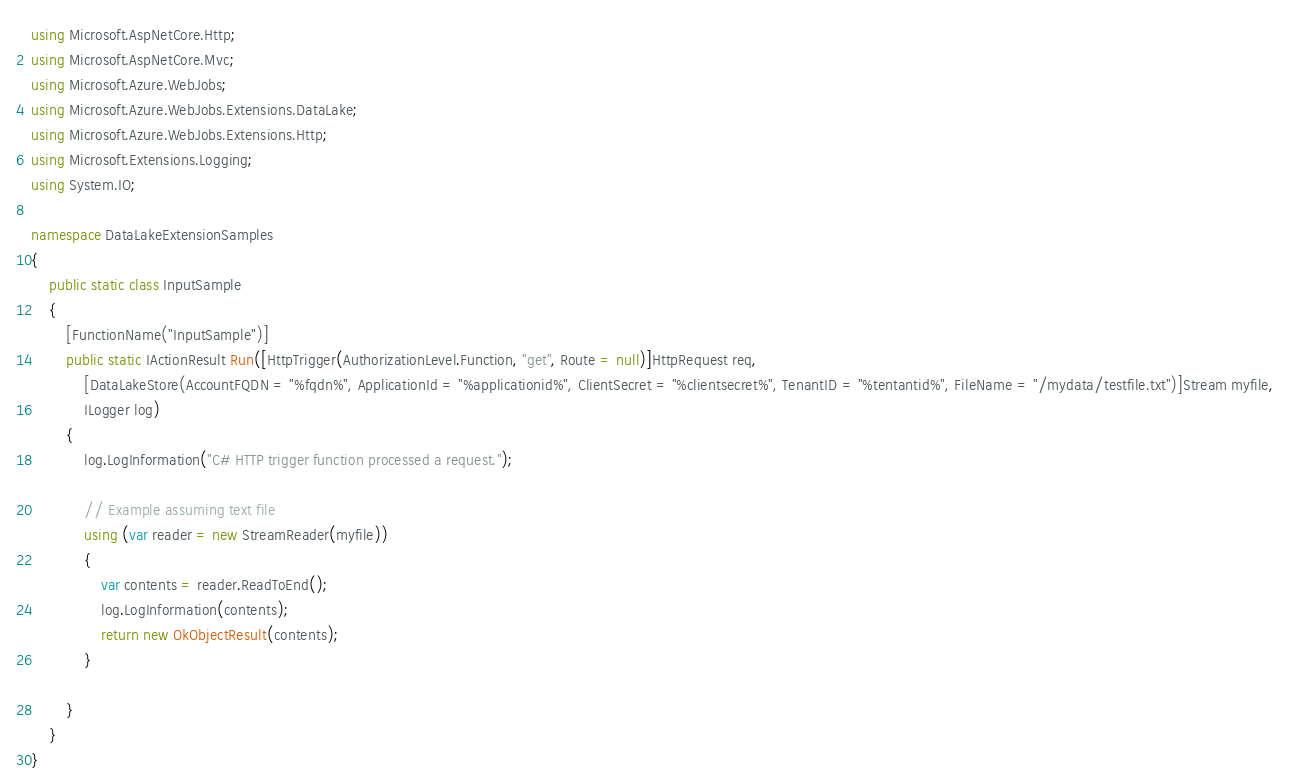<code> <loc_0><loc_0><loc_500><loc_500><_C#_>using Microsoft.AspNetCore.Http;
using Microsoft.AspNetCore.Mvc;
using Microsoft.Azure.WebJobs;
using Microsoft.Azure.WebJobs.Extensions.DataLake;
using Microsoft.Azure.WebJobs.Extensions.Http;
using Microsoft.Extensions.Logging;
using System.IO;

namespace DataLakeExtensionSamples
{
    public static class InputSample
    {
        [FunctionName("InputSample")]
        public static IActionResult Run([HttpTrigger(AuthorizationLevel.Function, "get", Route = null)]HttpRequest req,
            [DataLakeStore(AccountFQDN = "%fqdn%", ApplicationId = "%applicationid%", ClientSecret = "%clientsecret%", TenantID = "%tentantid%", FileName = "/mydata/testfile.txt")]Stream myfile,
            ILogger log)
        {
            log.LogInformation("C# HTTP trigger function processed a request.");

            // Example assuming text file 
            using (var reader = new StreamReader(myfile))
            {
                var contents = reader.ReadToEnd();
                log.LogInformation(contents);
                return new OkObjectResult(contents);
            }

        }
    }
}
</code> 